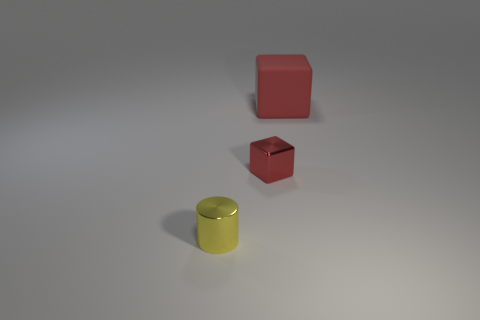Add 2 yellow objects. How many objects exist? 5 Subtract 2 cubes. How many cubes are left? 0 Subtract all red rubber cubes. Subtract all big metal spheres. How many objects are left? 2 Add 1 red matte objects. How many red matte objects are left? 2 Add 1 tiny yellow shiny cylinders. How many tiny yellow shiny cylinders exist? 2 Subtract 0 cyan spheres. How many objects are left? 3 Subtract all blocks. How many objects are left? 1 Subtract all cyan cylinders. Subtract all purple balls. How many cylinders are left? 1 